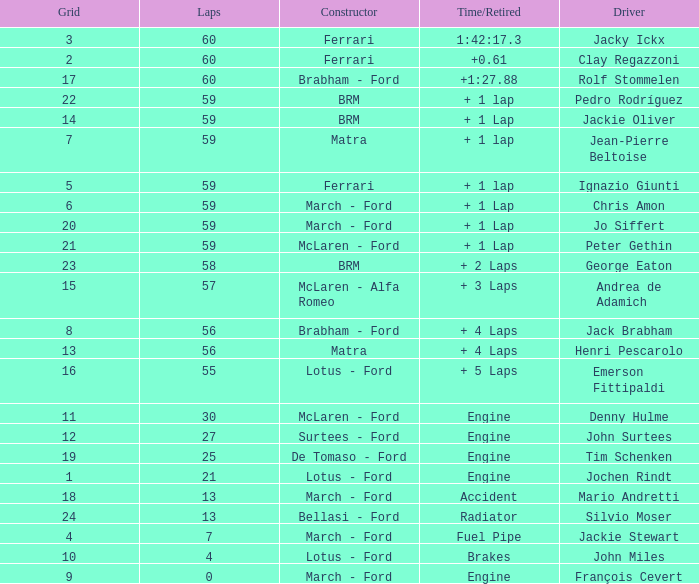I want the driver for grid of 9 François Cevert. 